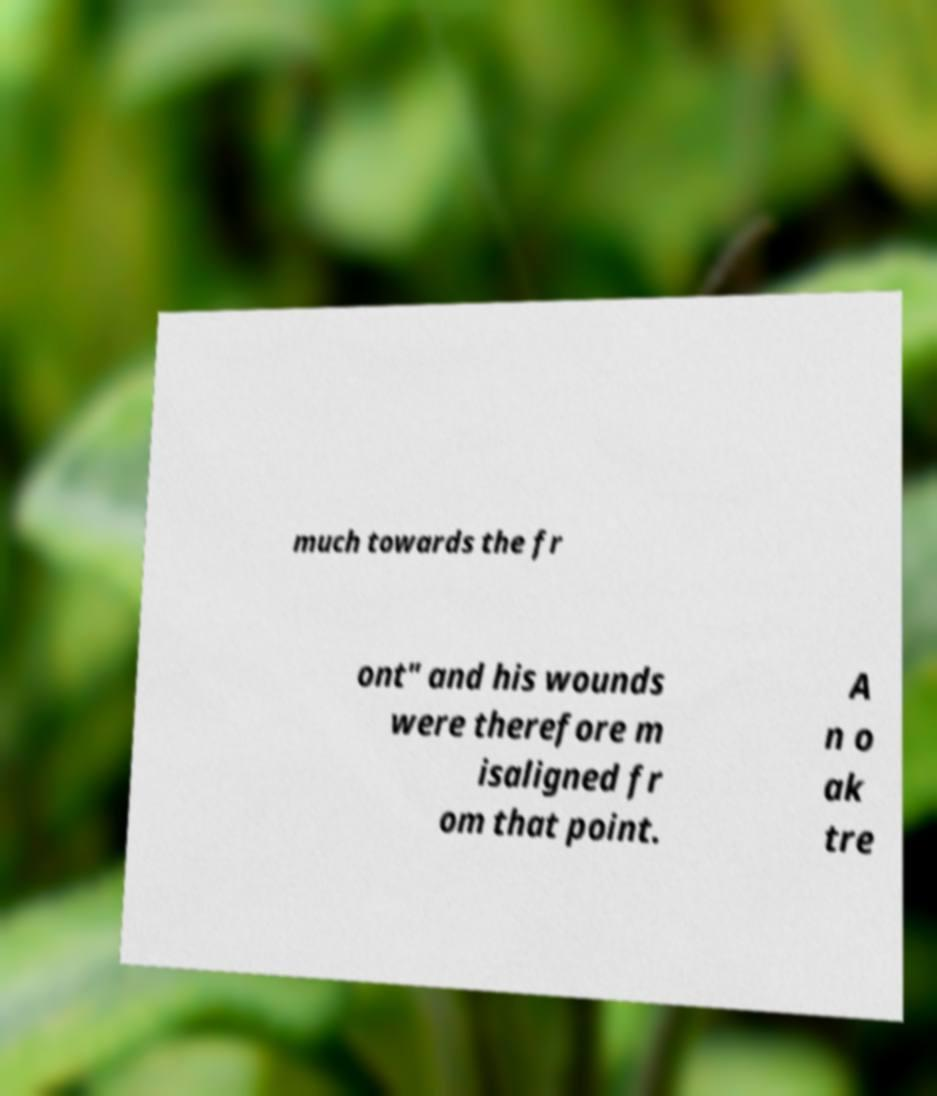Please identify and transcribe the text found in this image. much towards the fr ont" and his wounds were therefore m isaligned fr om that point. A n o ak tre 